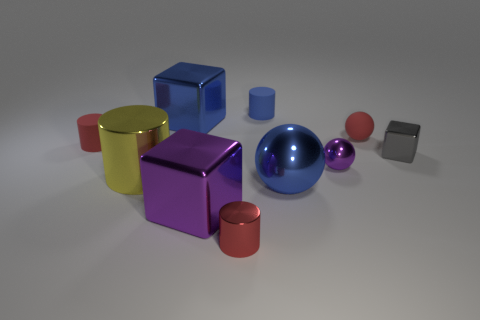Subtract all small cylinders. How many cylinders are left? 1 Subtract 3 balls. How many balls are left? 0 Subtract all yellow cylinders. How many cylinders are left? 3 Subtract all blocks. How many objects are left? 7 Subtract all gray spheres. How many gray blocks are left? 1 Add 5 purple cubes. How many purple cubes are left? 6 Add 7 tiny brown rubber things. How many tiny brown rubber things exist? 7 Subtract 0 brown cubes. How many objects are left? 10 Subtract all green cylinders. Subtract all brown spheres. How many cylinders are left? 4 Subtract all matte objects. Subtract all metal cubes. How many objects are left? 4 